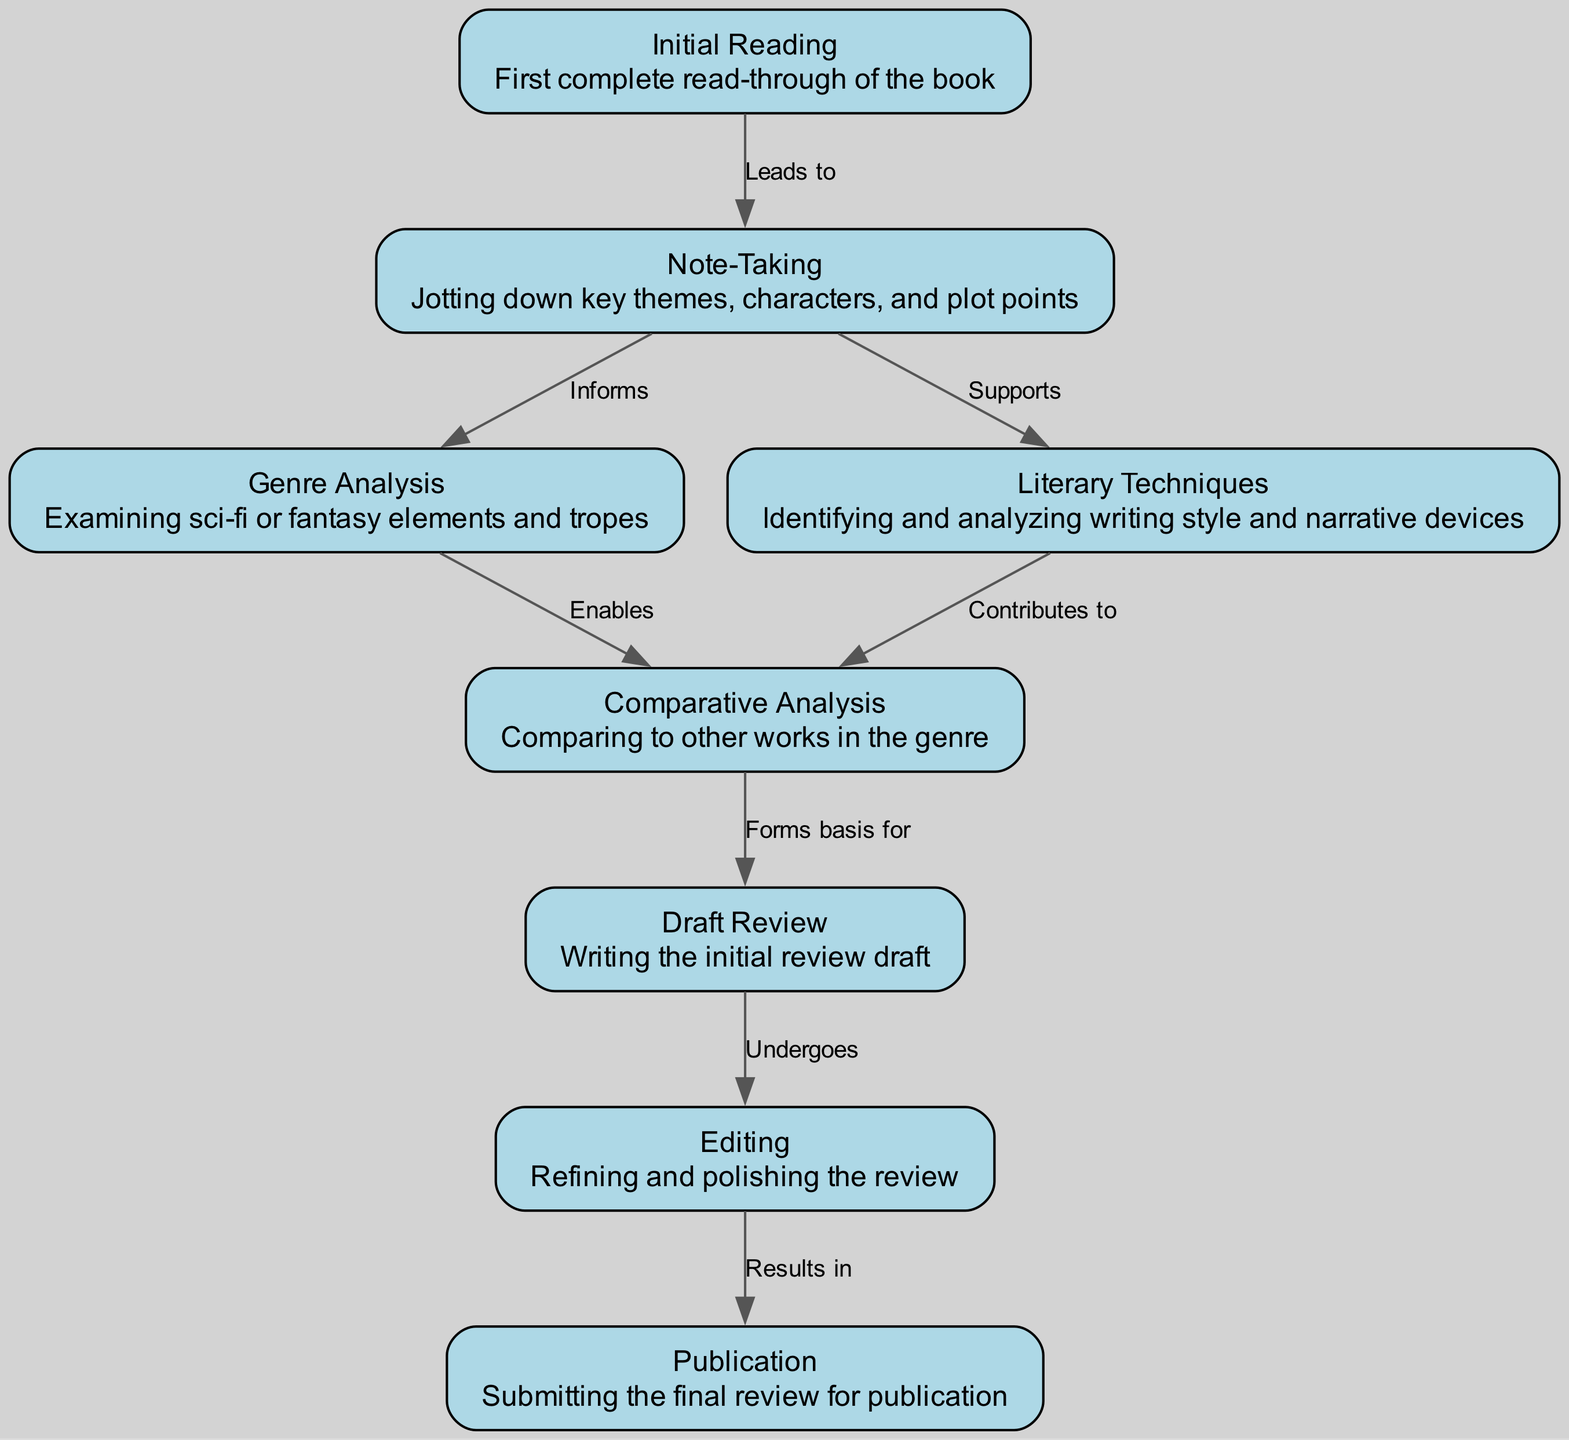What is the first step in the review process? The first step in the diagram is "Initial Reading," which outlines the first complete read-through of the book.
Answer: Initial Reading How many nodes are present in the diagram? By counting the nodes listed in the data, we find there are 8 nodes representing different steps in the review process.
Answer: 8 What does "Note-Taking" lead to? According to the diagram, "Note-Taking" leads to the steps of "Genre Analysis" and "Literary Techniques," indicating that jotting down notes helps in examining themes, characters, and plot points.
Answer: Genre Analysis and Literary Techniques Which step comes directly after "Draft Review"? The diagram shows that after "Draft Review," the next step is "Editing," where the initial review draft is refined and polished.
Answer: Editing In the diagram, which step "Forms basis for" the review? The diagram indicates that "Comparative Analysis" forms the basis for the "Draft Review," meaning that comparing to other works helps inform the writing of the review draft.
Answer: Draft Review What relationship does "Literary Techniques" have with "Comparative Analysis"? "Literary Techniques" contributes to "Comparative Analysis," suggesting that understanding literary devices aids in comparing works within the genre.
Answer: Contributes to How does "Editing" relate to "Publication"? The diagram indicates that "Editing" results in "Publication," implying that the refining process leads to the final submission of the review for publication.
Answer: Results in Which step undergoes refinement before publication? According to the diagram, the step that undergoes refinement is "Draft Review," which receives editing before moving on to publication.
Answer: Draft Review 